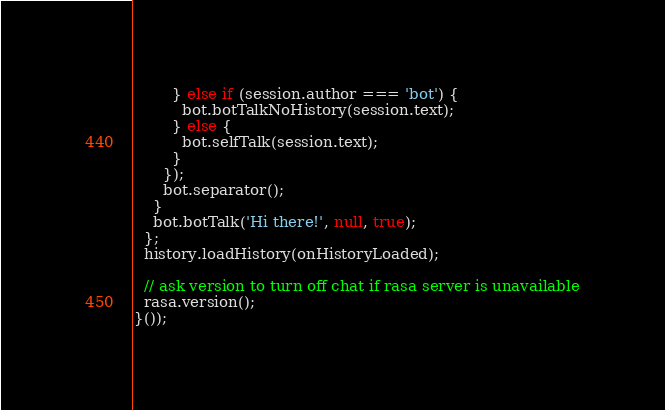<code> <loc_0><loc_0><loc_500><loc_500><_JavaScript_>        } else if (session.author === 'bot') {
          bot.botTalkNoHistory(session.text);
        } else {
          bot.selfTalk(session.text);
        }
      });
      bot.separator();
    }
    bot.botTalk('Hi there!', null, true);
  };
  history.loadHistory(onHistoryLoaded);

  // ask version to turn off chat if rasa server is unavailable
  rasa.version();
}());
</code> 